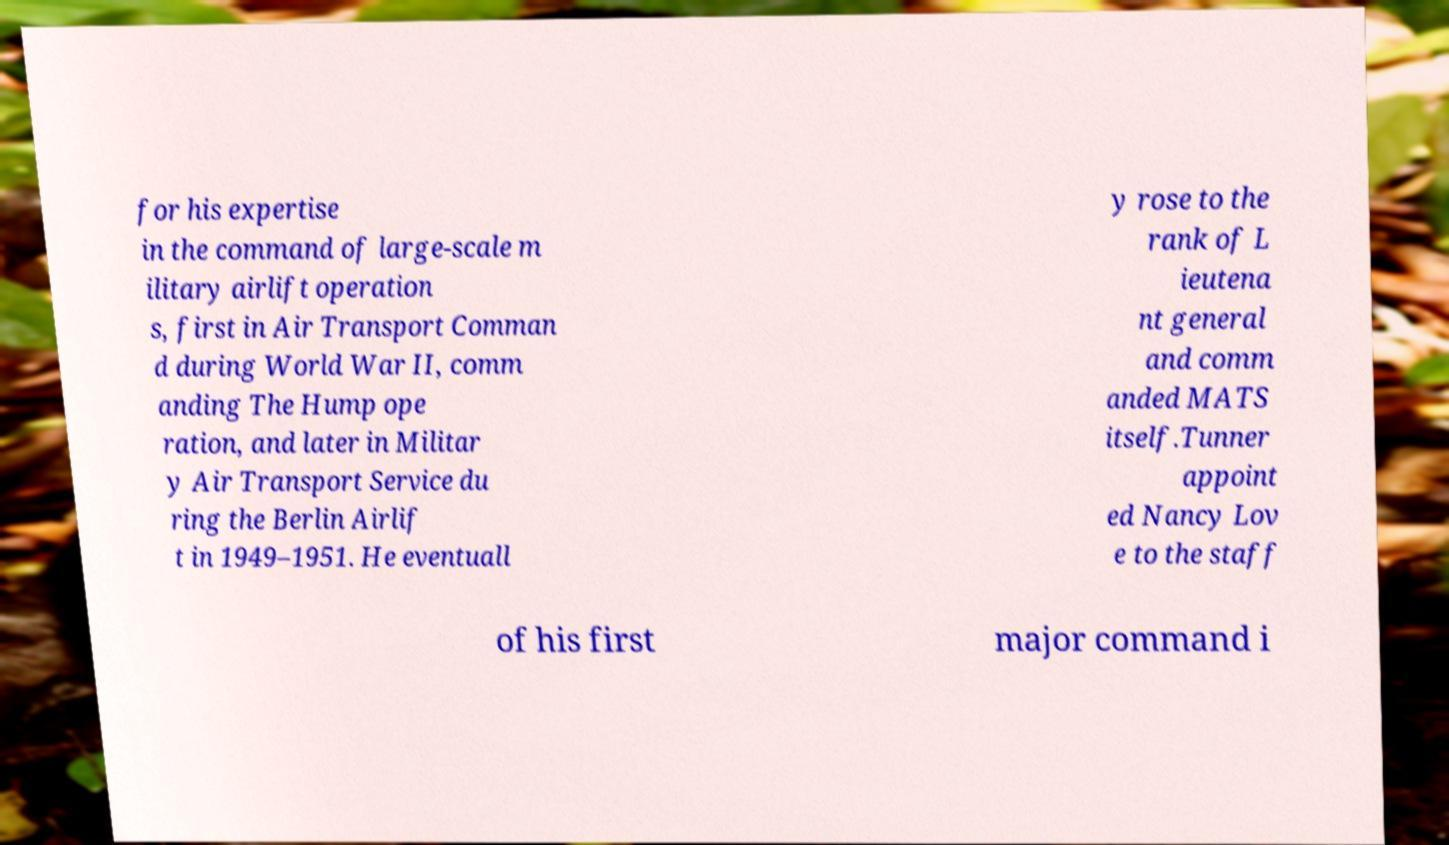Can you accurately transcribe the text from the provided image for me? for his expertise in the command of large-scale m ilitary airlift operation s, first in Air Transport Comman d during World War II, comm anding The Hump ope ration, and later in Militar y Air Transport Service du ring the Berlin Airlif t in 1949–1951. He eventuall y rose to the rank of L ieutena nt general and comm anded MATS itself.Tunner appoint ed Nancy Lov e to the staff of his first major command i 